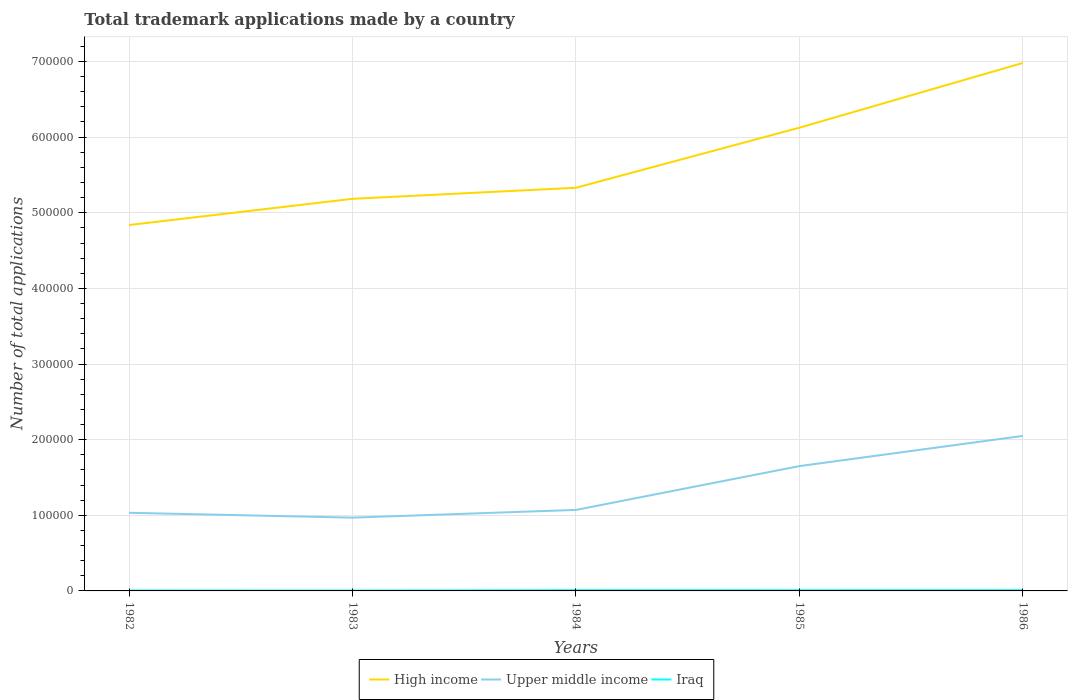Does the line corresponding to High income intersect with the line corresponding to Upper middle income?
Your answer should be very brief. No. Is the number of lines equal to the number of legend labels?
Keep it short and to the point. Yes. Across all years, what is the maximum number of applications made by in High income?
Make the answer very short. 4.84e+05. In which year was the number of applications made by in Upper middle income maximum?
Give a very brief answer. 1983. What is the total number of applications made by in Iraq in the graph?
Keep it short and to the point. -503. What is the difference between the highest and the second highest number of applications made by in Iraq?
Your answer should be compact. 503. What is the difference between the highest and the lowest number of applications made by in High income?
Offer a terse response. 2. Is the number of applications made by in Iraq strictly greater than the number of applications made by in High income over the years?
Provide a short and direct response. Yes. What is the difference between two consecutive major ticks on the Y-axis?
Your response must be concise. 1.00e+05. Are the values on the major ticks of Y-axis written in scientific E-notation?
Offer a very short reply. No. Does the graph contain grids?
Offer a terse response. Yes. Where does the legend appear in the graph?
Keep it short and to the point. Bottom center. What is the title of the graph?
Offer a terse response. Total trademark applications made by a country. What is the label or title of the X-axis?
Your answer should be very brief. Years. What is the label or title of the Y-axis?
Provide a short and direct response. Number of total applications. What is the Number of total applications of High income in 1982?
Ensure brevity in your answer.  4.84e+05. What is the Number of total applications in Upper middle income in 1982?
Your answer should be compact. 1.03e+05. What is the Number of total applications of Iraq in 1982?
Make the answer very short. 588. What is the Number of total applications of High income in 1983?
Offer a terse response. 5.18e+05. What is the Number of total applications of Upper middle income in 1983?
Ensure brevity in your answer.  9.69e+04. What is the Number of total applications of Iraq in 1983?
Keep it short and to the point. 491. What is the Number of total applications in High income in 1984?
Offer a terse response. 5.33e+05. What is the Number of total applications in Upper middle income in 1984?
Keep it short and to the point. 1.07e+05. What is the Number of total applications in Iraq in 1984?
Ensure brevity in your answer.  994. What is the Number of total applications of High income in 1985?
Your answer should be compact. 6.12e+05. What is the Number of total applications of Upper middle income in 1985?
Offer a very short reply. 1.65e+05. What is the Number of total applications in Iraq in 1985?
Provide a succinct answer. 934. What is the Number of total applications of High income in 1986?
Keep it short and to the point. 6.98e+05. What is the Number of total applications of Upper middle income in 1986?
Give a very brief answer. 2.05e+05. What is the Number of total applications in Iraq in 1986?
Offer a very short reply. 988. Across all years, what is the maximum Number of total applications of High income?
Your answer should be very brief. 6.98e+05. Across all years, what is the maximum Number of total applications of Upper middle income?
Keep it short and to the point. 2.05e+05. Across all years, what is the maximum Number of total applications in Iraq?
Provide a succinct answer. 994. Across all years, what is the minimum Number of total applications of High income?
Your answer should be very brief. 4.84e+05. Across all years, what is the minimum Number of total applications in Upper middle income?
Offer a terse response. 9.69e+04. Across all years, what is the minimum Number of total applications of Iraq?
Give a very brief answer. 491. What is the total Number of total applications in High income in the graph?
Provide a succinct answer. 2.85e+06. What is the total Number of total applications of Upper middle income in the graph?
Provide a succinct answer. 6.77e+05. What is the total Number of total applications in Iraq in the graph?
Your response must be concise. 3995. What is the difference between the Number of total applications of High income in 1982 and that in 1983?
Your response must be concise. -3.46e+04. What is the difference between the Number of total applications of Upper middle income in 1982 and that in 1983?
Your response must be concise. 6436. What is the difference between the Number of total applications in Iraq in 1982 and that in 1983?
Ensure brevity in your answer.  97. What is the difference between the Number of total applications in High income in 1982 and that in 1984?
Give a very brief answer. -4.93e+04. What is the difference between the Number of total applications in Upper middle income in 1982 and that in 1984?
Provide a succinct answer. -3796. What is the difference between the Number of total applications of Iraq in 1982 and that in 1984?
Your answer should be very brief. -406. What is the difference between the Number of total applications of High income in 1982 and that in 1985?
Give a very brief answer. -1.29e+05. What is the difference between the Number of total applications in Upper middle income in 1982 and that in 1985?
Give a very brief answer. -6.17e+04. What is the difference between the Number of total applications of Iraq in 1982 and that in 1985?
Your answer should be very brief. -346. What is the difference between the Number of total applications of High income in 1982 and that in 1986?
Your answer should be compact. -2.14e+05. What is the difference between the Number of total applications of Upper middle income in 1982 and that in 1986?
Your answer should be compact. -1.02e+05. What is the difference between the Number of total applications in Iraq in 1982 and that in 1986?
Your response must be concise. -400. What is the difference between the Number of total applications of High income in 1983 and that in 1984?
Offer a very short reply. -1.46e+04. What is the difference between the Number of total applications in Upper middle income in 1983 and that in 1984?
Offer a very short reply. -1.02e+04. What is the difference between the Number of total applications in Iraq in 1983 and that in 1984?
Offer a terse response. -503. What is the difference between the Number of total applications in High income in 1983 and that in 1985?
Your response must be concise. -9.41e+04. What is the difference between the Number of total applications of Upper middle income in 1983 and that in 1985?
Your response must be concise. -6.82e+04. What is the difference between the Number of total applications of Iraq in 1983 and that in 1985?
Your answer should be very brief. -443. What is the difference between the Number of total applications in High income in 1983 and that in 1986?
Provide a short and direct response. -1.80e+05. What is the difference between the Number of total applications of Upper middle income in 1983 and that in 1986?
Keep it short and to the point. -1.08e+05. What is the difference between the Number of total applications of Iraq in 1983 and that in 1986?
Ensure brevity in your answer.  -497. What is the difference between the Number of total applications of High income in 1984 and that in 1985?
Give a very brief answer. -7.94e+04. What is the difference between the Number of total applications in Upper middle income in 1984 and that in 1985?
Ensure brevity in your answer.  -5.79e+04. What is the difference between the Number of total applications of Iraq in 1984 and that in 1985?
Give a very brief answer. 60. What is the difference between the Number of total applications of High income in 1984 and that in 1986?
Keep it short and to the point. -1.65e+05. What is the difference between the Number of total applications in Upper middle income in 1984 and that in 1986?
Your response must be concise. -9.78e+04. What is the difference between the Number of total applications in High income in 1985 and that in 1986?
Offer a terse response. -8.56e+04. What is the difference between the Number of total applications of Upper middle income in 1985 and that in 1986?
Give a very brief answer. -3.99e+04. What is the difference between the Number of total applications in Iraq in 1985 and that in 1986?
Offer a terse response. -54. What is the difference between the Number of total applications of High income in 1982 and the Number of total applications of Upper middle income in 1983?
Offer a terse response. 3.87e+05. What is the difference between the Number of total applications of High income in 1982 and the Number of total applications of Iraq in 1983?
Keep it short and to the point. 4.83e+05. What is the difference between the Number of total applications in Upper middle income in 1982 and the Number of total applications in Iraq in 1983?
Provide a succinct answer. 1.03e+05. What is the difference between the Number of total applications of High income in 1982 and the Number of total applications of Upper middle income in 1984?
Offer a very short reply. 3.77e+05. What is the difference between the Number of total applications of High income in 1982 and the Number of total applications of Iraq in 1984?
Provide a succinct answer. 4.83e+05. What is the difference between the Number of total applications of Upper middle income in 1982 and the Number of total applications of Iraq in 1984?
Your answer should be very brief. 1.02e+05. What is the difference between the Number of total applications of High income in 1982 and the Number of total applications of Upper middle income in 1985?
Keep it short and to the point. 3.19e+05. What is the difference between the Number of total applications in High income in 1982 and the Number of total applications in Iraq in 1985?
Give a very brief answer. 4.83e+05. What is the difference between the Number of total applications in Upper middle income in 1982 and the Number of total applications in Iraq in 1985?
Provide a short and direct response. 1.02e+05. What is the difference between the Number of total applications of High income in 1982 and the Number of total applications of Upper middle income in 1986?
Your response must be concise. 2.79e+05. What is the difference between the Number of total applications of High income in 1982 and the Number of total applications of Iraq in 1986?
Your answer should be compact. 4.83e+05. What is the difference between the Number of total applications in Upper middle income in 1982 and the Number of total applications in Iraq in 1986?
Offer a terse response. 1.02e+05. What is the difference between the Number of total applications in High income in 1983 and the Number of total applications in Upper middle income in 1984?
Offer a very short reply. 4.11e+05. What is the difference between the Number of total applications of High income in 1983 and the Number of total applications of Iraq in 1984?
Your answer should be compact. 5.17e+05. What is the difference between the Number of total applications in Upper middle income in 1983 and the Number of total applications in Iraq in 1984?
Your answer should be very brief. 9.59e+04. What is the difference between the Number of total applications in High income in 1983 and the Number of total applications in Upper middle income in 1985?
Make the answer very short. 3.53e+05. What is the difference between the Number of total applications of High income in 1983 and the Number of total applications of Iraq in 1985?
Offer a terse response. 5.17e+05. What is the difference between the Number of total applications of Upper middle income in 1983 and the Number of total applications of Iraq in 1985?
Keep it short and to the point. 9.59e+04. What is the difference between the Number of total applications in High income in 1983 and the Number of total applications in Upper middle income in 1986?
Your response must be concise. 3.13e+05. What is the difference between the Number of total applications of High income in 1983 and the Number of total applications of Iraq in 1986?
Provide a succinct answer. 5.17e+05. What is the difference between the Number of total applications in Upper middle income in 1983 and the Number of total applications in Iraq in 1986?
Provide a short and direct response. 9.59e+04. What is the difference between the Number of total applications of High income in 1984 and the Number of total applications of Upper middle income in 1985?
Ensure brevity in your answer.  3.68e+05. What is the difference between the Number of total applications of High income in 1984 and the Number of total applications of Iraq in 1985?
Your answer should be compact. 5.32e+05. What is the difference between the Number of total applications in Upper middle income in 1984 and the Number of total applications in Iraq in 1985?
Give a very brief answer. 1.06e+05. What is the difference between the Number of total applications of High income in 1984 and the Number of total applications of Upper middle income in 1986?
Provide a succinct answer. 3.28e+05. What is the difference between the Number of total applications of High income in 1984 and the Number of total applications of Iraq in 1986?
Your response must be concise. 5.32e+05. What is the difference between the Number of total applications in Upper middle income in 1984 and the Number of total applications in Iraq in 1986?
Provide a succinct answer. 1.06e+05. What is the difference between the Number of total applications of High income in 1985 and the Number of total applications of Upper middle income in 1986?
Keep it short and to the point. 4.08e+05. What is the difference between the Number of total applications of High income in 1985 and the Number of total applications of Iraq in 1986?
Make the answer very short. 6.11e+05. What is the difference between the Number of total applications in Upper middle income in 1985 and the Number of total applications in Iraq in 1986?
Provide a succinct answer. 1.64e+05. What is the average Number of total applications in High income per year?
Make the answer very short. 5.69e+05. What is the average Number of total applications in Upper middle income per year?
Your answer should be very brief. 1.35e+05. What is the average Number of total applications of Iraq per year?
Give a very brief answer. 799. In the year 1982, what is the difference between the Number of total applications in High income and Number of total applications in Upper middle income?
Offer a very short reply. 3.80e+05. In the year 1982, what is the difference between the Number of total applications in High income and Number of total applications in Iraq?
Keep it short and to the point. 4.83e+05. In the year 1982, what is the difference between the Number of total applications of Upper middle income and Number of total applications of Iraq?
Your response must be concise. 1.03e+05. In the year 1983, what is the difference between the Number of total applications of High income and Number of total applications of Upper middle income?
Provide a succinct answer. 4.22e+05. In the year 1983, what is the difference between the Number of total applications in High income and Number of total applications in Iraq?
Offer a terse response. 5.18e+05. In the year 1983, what is the difference between the Number of total applications of Upper middle income and Number of total applications of Iraq?
Give a very brief answer. 9.64e+04. In the year 1984, what is the difference between the Number of total applications of High income and Number of total applications of Upper middle income?
Your response must be concise. 4.26e+05. In the year 1984, what is the difference between the Number of total applications in High income and Number of total applications in Iraq?
Make the answer very short. 5.32e+05. In the year 1984, what is the difference between the Number of total applications in Upper middle income and Number of total applications in Iraq?
Provide a short and direct response. 1.06e+05. In the year 1985, what is the difference between the Number of total applications of High income and Number of total applications of Upper middle income?
Give a very brief answer. 4.47e+05. In the year 1985, what is the difference between the Number of total applications in High income and Number of total applications in Iraq?
Ensure brevity in your answer.  6.12e+05. In the year 1985, what is the difference between the Number of total applications of Upper middle income and Number of total applications of Iraq?
Your answer should be very brief. 1.64e+05. In the year 1986, what is the difference between the Number of total applications of High income and Number of total applications of Upper middle income?
Offer a very short reply. 4.93e+05. In the year 1986, what is the difference between the Number of total applications in High income and Number of total applications in Iraq?
Ensure brevity in your answer.  6.97e+05. In the year 1986, what is the difference between the Number of total applications of Upper middle income and Number of total applications of Iraq?
Provide a succinct answer. 2.04e+05. What is the ratio of the Number of total applications in High income in 1982 to that in 1983?
Ensure brevity in your answer.  0.93. What is the ratio of the Number of total applications of Upper middle income in 1982 to that in 1983?
Offer a very short reply. 1.07. What is the ratio of the Number of total applications of Iraq in 1982 to that in 1983?
Your response must be concise. 1.2. What is the ratio of the Number of total applications of High income in 1982 to that in 1984?
Make the answer very short. 0.91. What is the ratio of the Number of total applications in Upper middle income in 1982 to that in 1984?
Give a very brief answer. 0.96. What is the ratio of the Number of total applications in Iraq in 1982 to that in 1984?
Ensure brevity in your answer.  0.59. What is the ratio of the Number of total applications of High income in 1982 to that in 1985?
Ensure brevity in your answer.  0.79. What is the ratio of the Number of total applications of Upper middle income in 1982 to that in 1985?
Keep it short and to the point. 0.63. What is the ratio of the Number of total applications of Iraq in 1982 to that in 1985?
Your answer should be compact. 0.63. What is the ratio of the Number of total applications of High income in 1982 to that in 1986?
Offer a terse response. 0.69. What is the ratio of the Number of total applications in Upper middle income in 1982 to that in 1986?
Provide a short and direct response. 0.5. What is the ratio of the Number of total applications in Iraq in 1982 to that in 1986?
Make the answer very short. 0.6. What is the ratio of the Number of total applications in High income in 1983 to that in 1984?
Provide a short and direct response. 0.97. What is the ratio of the Number of total applications of Upper middle income in 1983 to that in 1984?
Your response must be concise. 0.9. What is the ratio of the Number of total applications in Iraq in 1983 to that in 1984?
Keep it short and to the point. 0.49. What is the ratio of the Number of total applications of High income in 1983 to that in 1985?
Your answer should be very brief. 0.85. What is the ratio of the Number of total applications of Upper middle income in 1983 to that in 1985?
Your answer should be very brief. 0.59. What is the ratio of the Number of total applications in Iraq in 1983 to that in 1985?
Keep it short and to the point. 0.53. What is the ratio of the Number of total applications in High income in 1983 to that in 1986?
Your answer should be compact. 0.74. What is the ratio of the Number of total applications in Upper middle income in 1983 to that in 1986?
Your response must be concise. 0.47. What is the ratio of the Number of total applications in Iraq in 1983 to that in 1986?
Your answer should be compact. 0.5. What is the ratio of the Number of total applications in High income in 1984 to that in 1985?
Offer a very short reply. 0.87. What is the ratio of the Number of total applications of Upper middle income in 1984 to that in 1985?
Offer a very short reply. 0.65. What is the ratio of the Number of total applications in Iraq in 1984 to that in 1985?
Keep it short and to the point. 1.06. What is the ratio of the Number of total applications of High income in 1984 to that in 1986?
Your response must be concise. 0.76. What is the ratio of the Number of total applications of Upper middle income in 1984 to that in 1986?
Your answer should be very brief. 0.52. What is the ratio of the Number of total applications in High income in 1985 to that in 1986?
Keep it short and to the point. 0.88. What is the ratio of the Number of total applications of Upper middle income in 1985 to that in 1986?
Your answer should be compact. 0.81. What is the ratio of the Number of total applications of Iraq in 1985 to that in 1986?
Your answer should be very brief. 0.95. What is the difference between the highest and the second highest Number of total applications of High income?
Provide a succinct answer. 8.56e+04. What is the difference between the highest and the second highest Number of total applications of Upper middle income?
Your answer should be very brief. 3.99e+04. What is the difference between the highest and the second highest Number of total applications in Iraq?
Offer a terse response. 6. What is the difference between the highest and the lowest Number of total applications in High income?
Make the answer very short. 2.14e+05. What is the difference between the highest and the lowest Number of total applications in Upper middle income?
Your answer should be very brief. 1.08e+05. What is the difference between the highest and the lowest Number of total applications in Iraq?
Offer a terse response. 503. 